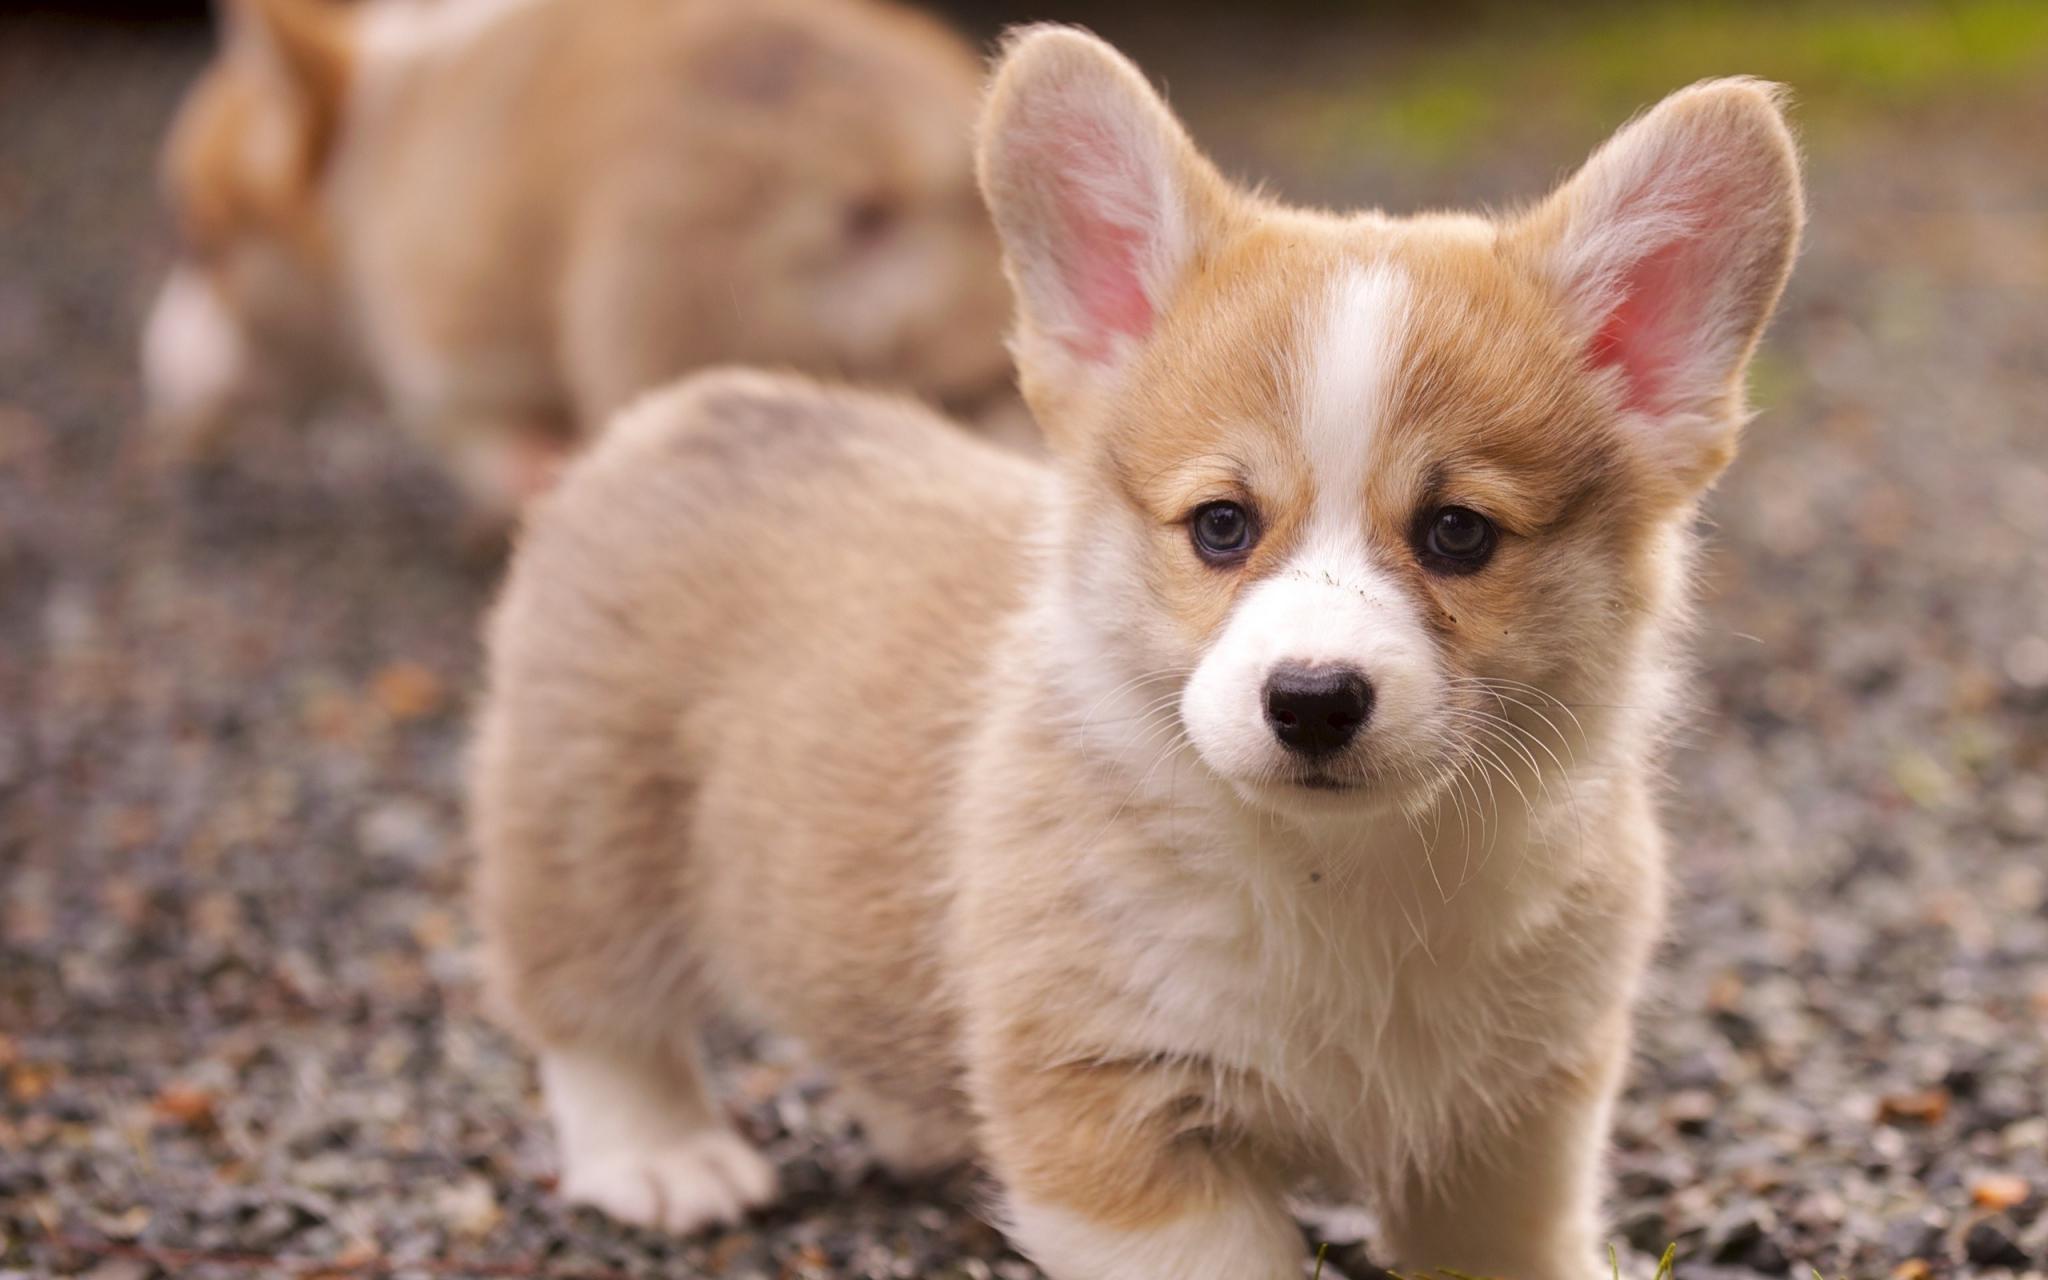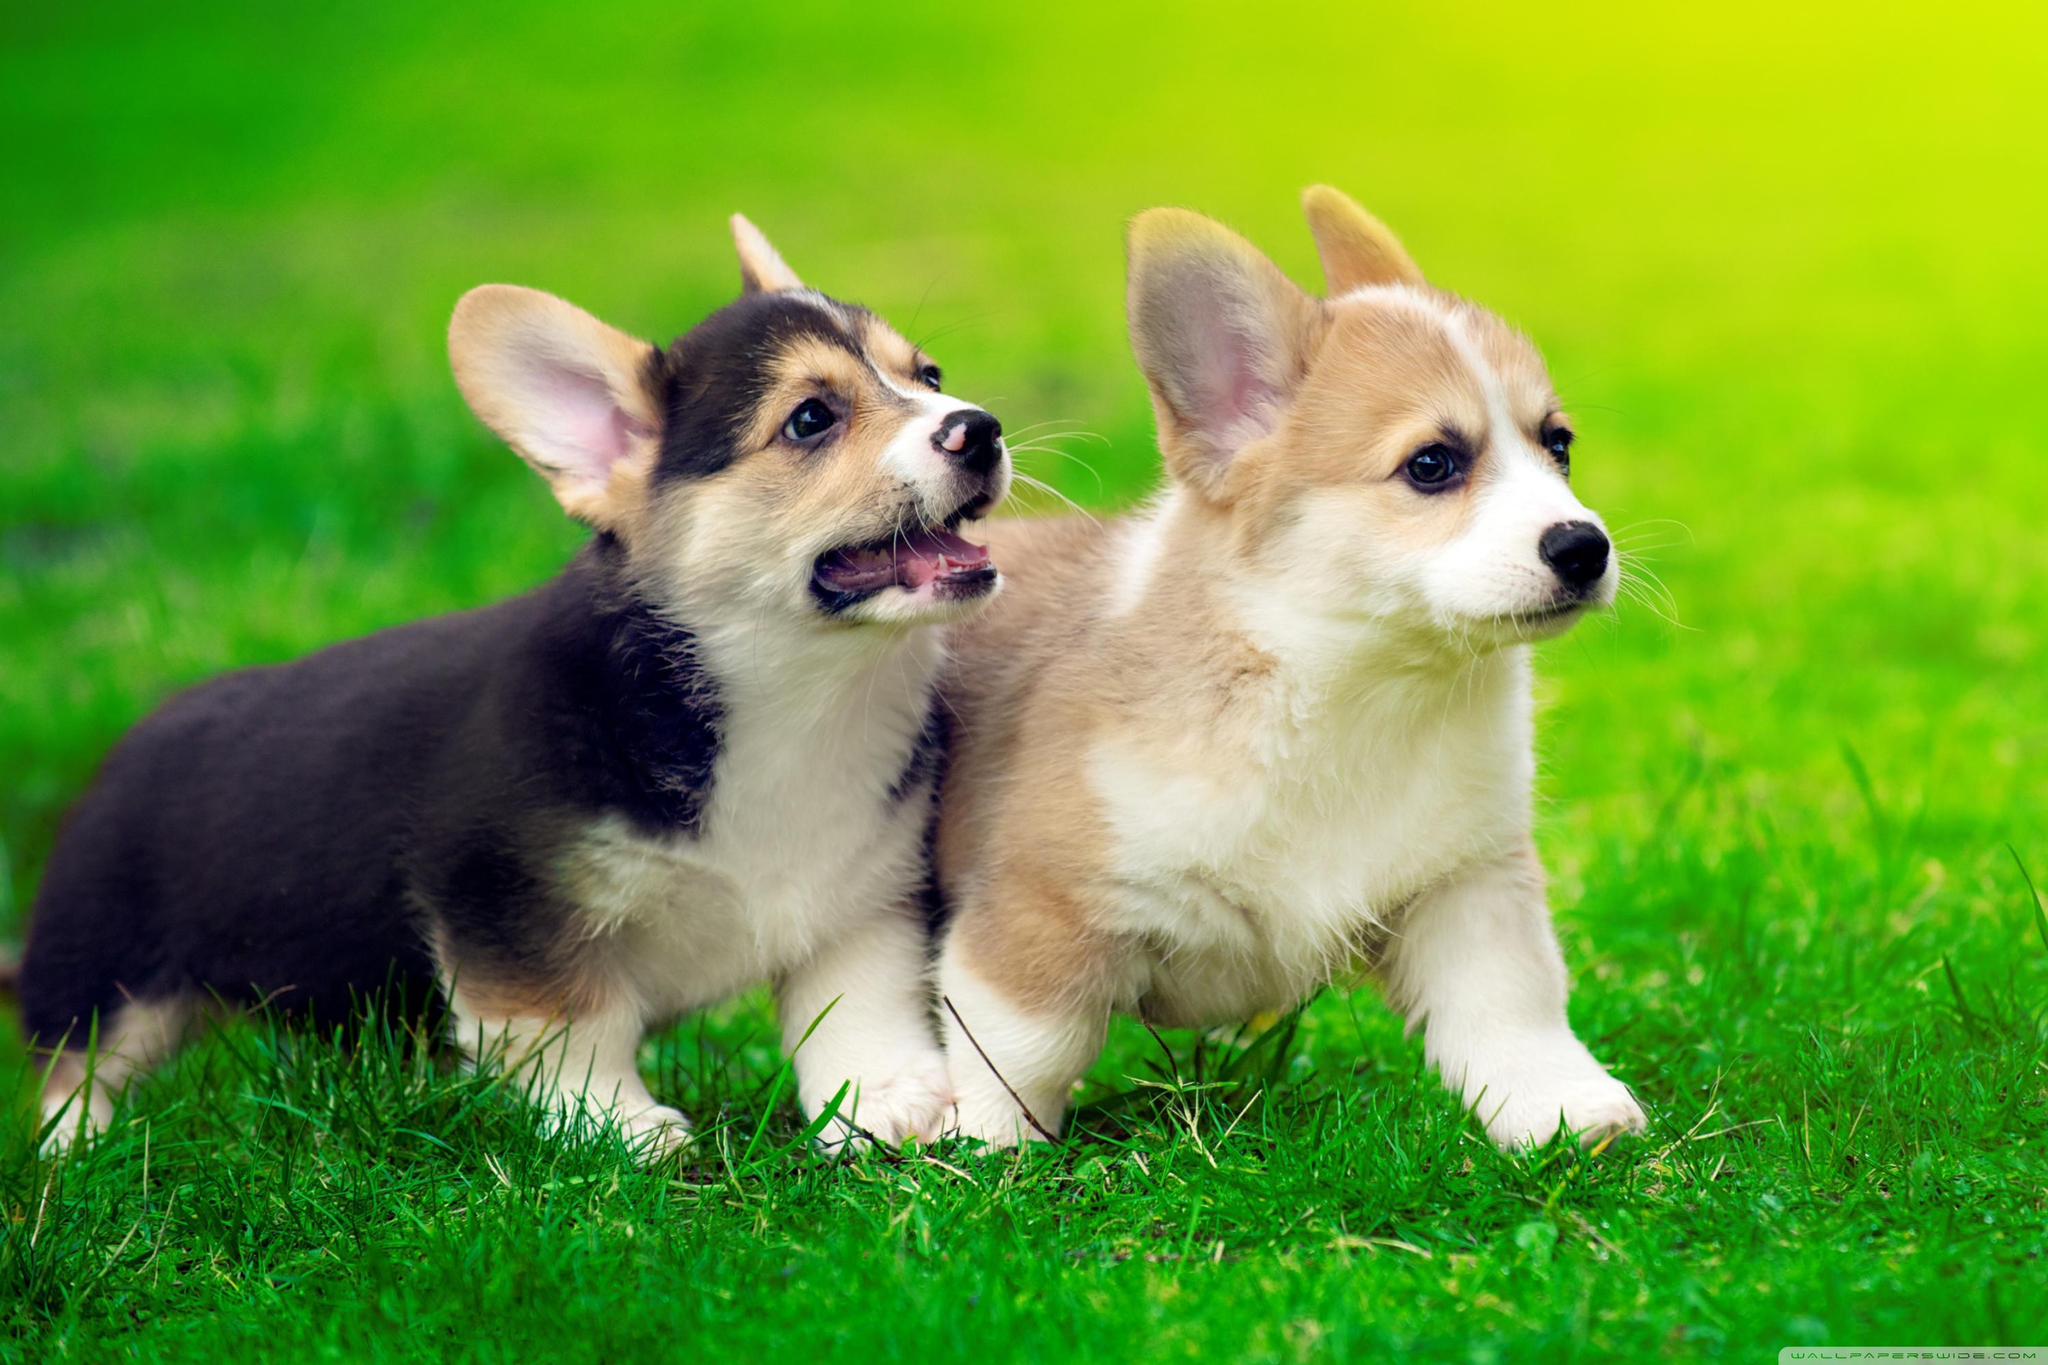The first image is the image on the left, the second image is the image on the right. For the images displayed, is the sentence "The right image contains exactly two dogs." factually correct? Answer yes or no. Yes. 